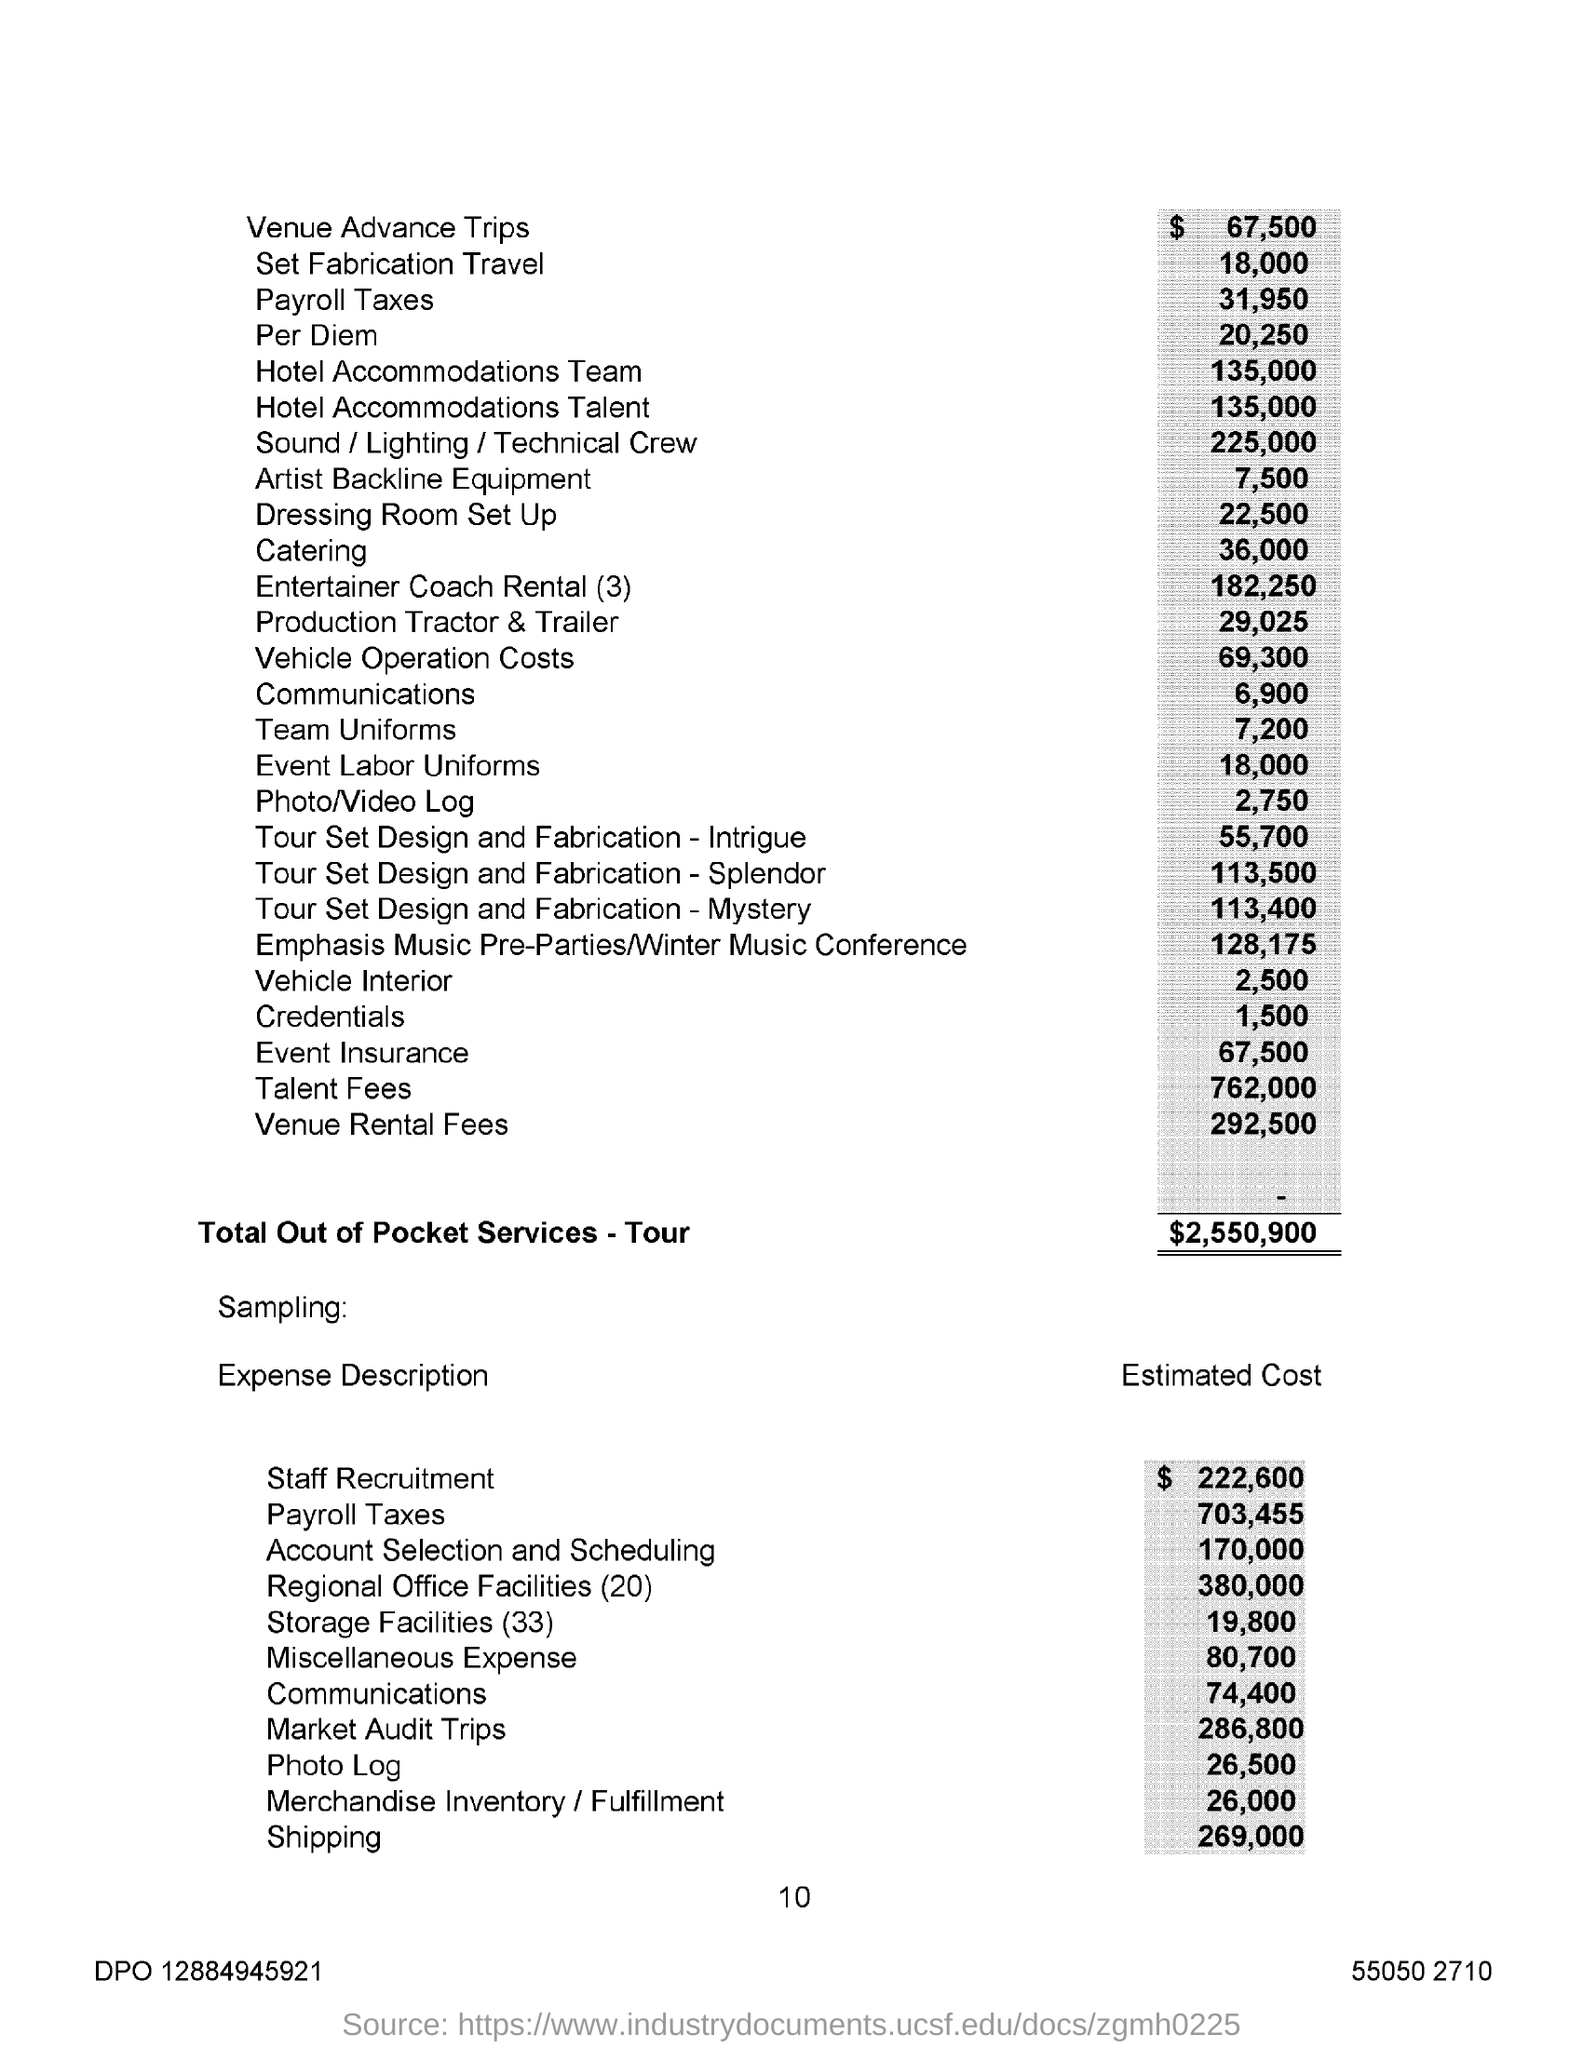List a handful of essential elements in this visual. The total out-of-pocket services for the tour is $2,550,900. The estimated cost for shipping is $269,000. 